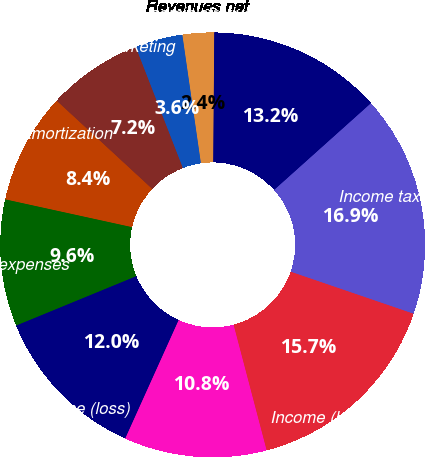<chart> <loc_0><loc_0><loc_500><loc_500><pie_chart><fcel>Revenues net<fcel>General and administrative<fcel>Advertising and marketing<fcel>Depreciation and amortization<fcel>Total operating expenses<fcel>Operating income (loss)<fcel>Total other income (expense)<fcel>Income (loss) before income<fcel>Income tax expense (benefit)<fcel>Net income (loss)<nl><fcel>2.41%<fcel>3.62%<fcel>7.23%<fcel>8.43%<fcel>9.64%<fcel>12.05%<fcel>10.84%<fcel>15.66%<fcel>16.87%<fcel>13.25%<nl></chart> 